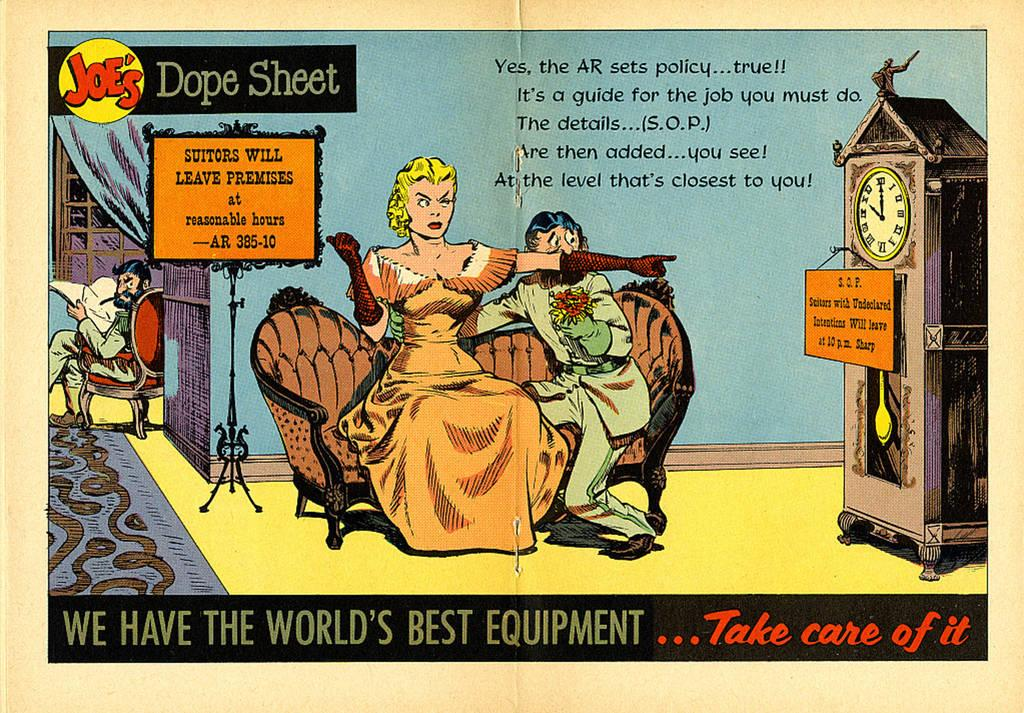<image>
Render a clear and concise summary of the photo. Drawing sohwing two people under some words that say "Dope Sheet". 